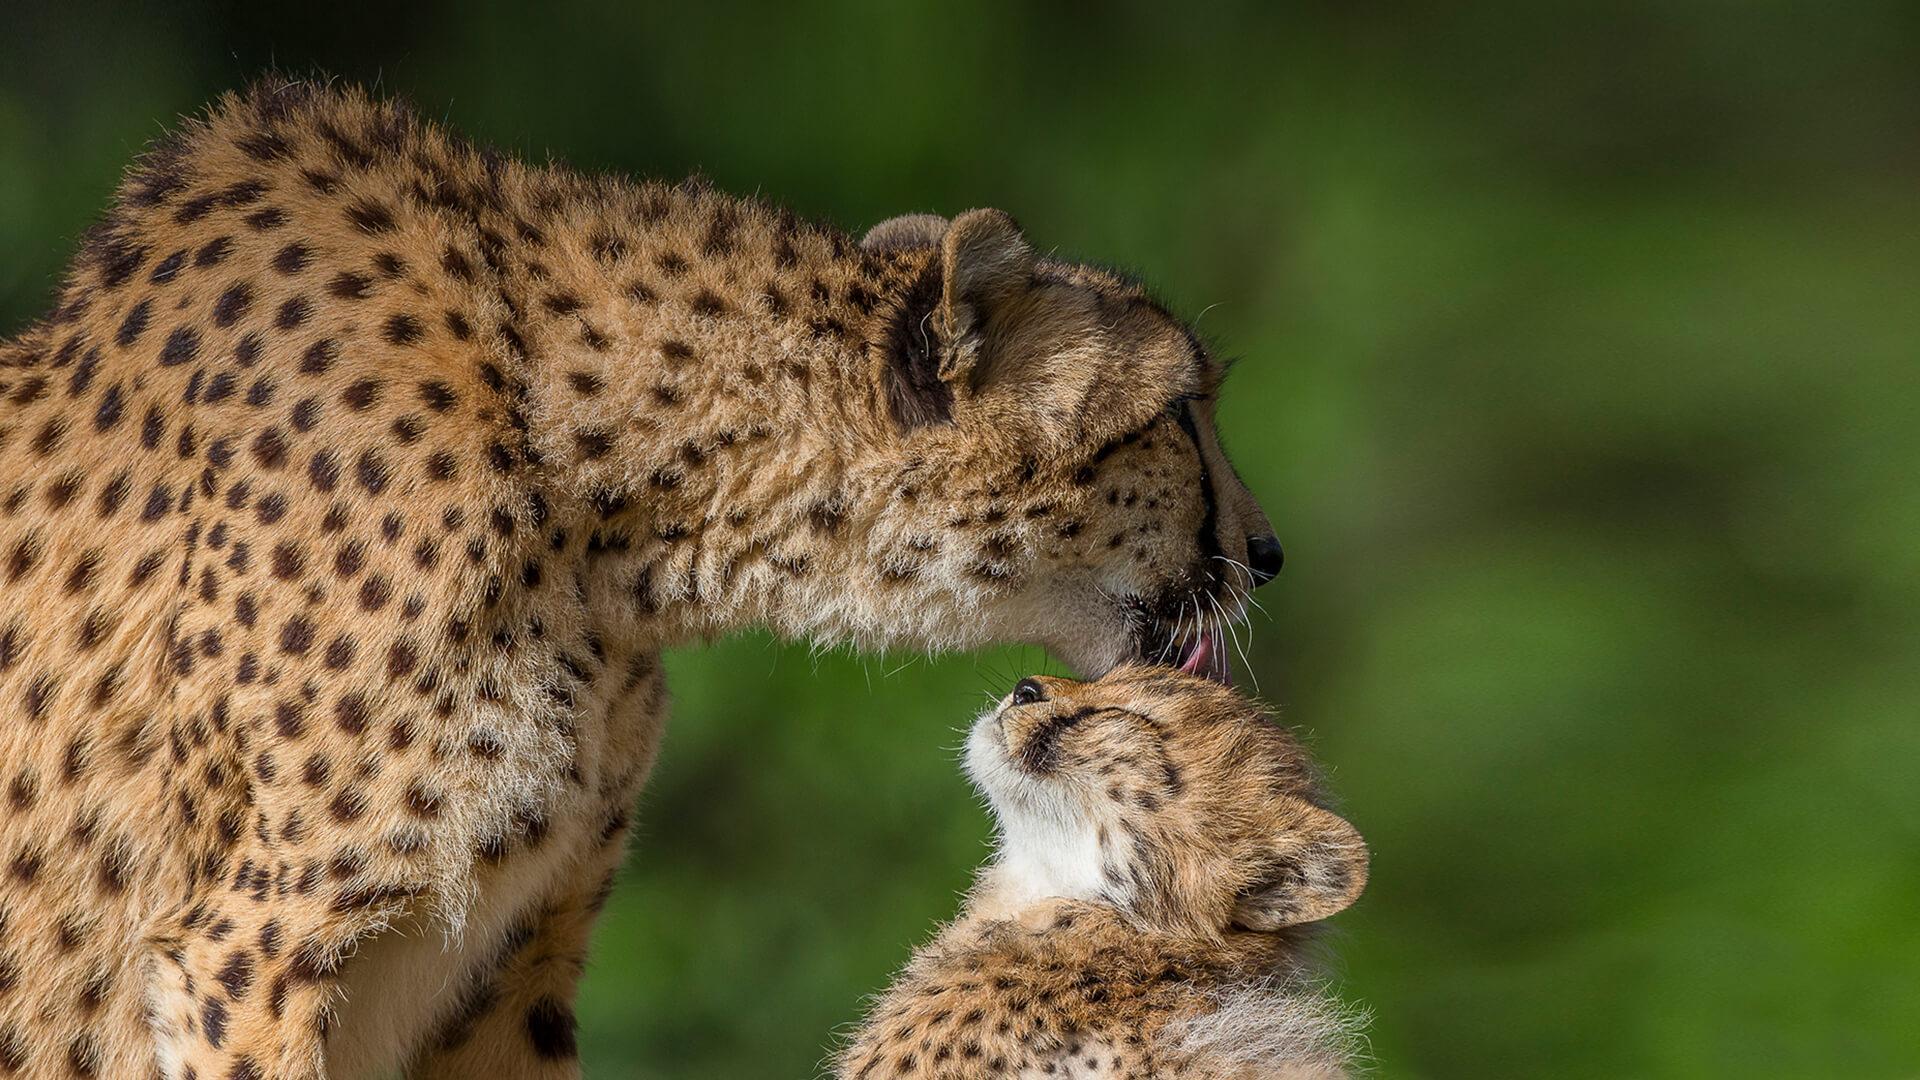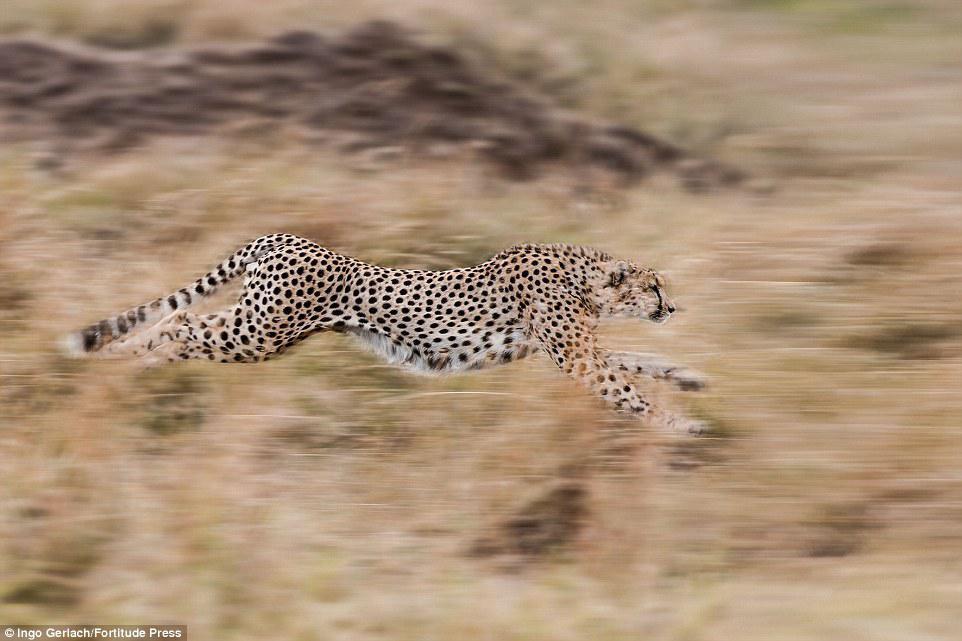The first image is the image on the left, the second image is the image on the right. For the images displayed, is the sentence "At least one image shows a spotted wild cat pursuing a gazelle-type prey animal." factually correct? Answer yes or no. No. The first image is the image on the left, the second image is the image on the right. Evaluate the accuracy of this statement regarding the images: "At least one of the animals is chasing its prey.". Is it true? Answer yes or no. No. 